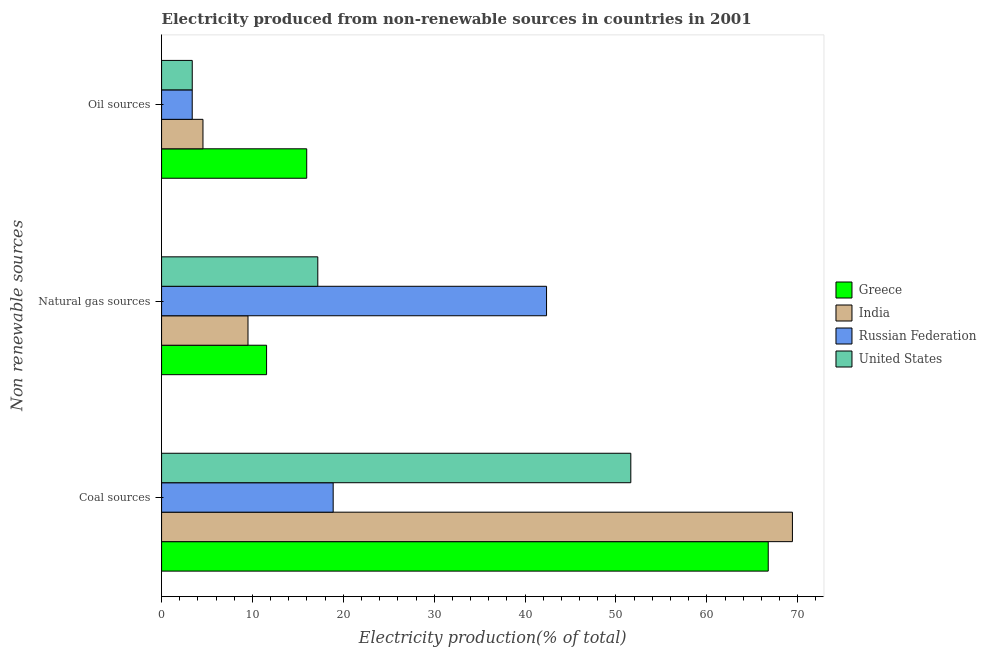How many different coloured bars are there?
Offer a very short reply. 4. How many groups of bars are there?
Keep it short and to the point. 3. How many bars are there on the 3rd tick from the top?
Your answer should be compact. 4. What is the label of the 3rd group of bars from the top?
Ensure brevity in your answer.  Coal sources. What is the percentage of electricity produced by natural gas in India?
Offer a terse response. 9.51. Across all countries, what is the maximum percentage of electricity produced by natural gas?
Offer a very short reply. 42.36. Across all countries, what is the minimum percentage of electricity produced by natural gas?
Your response must be concise. 9.51. In which country was the percentage of electricity produced by coal minimum?
Provide a short and direct response. Russian Federation. What is the total percentage of electricity produced by coal in the graph?
Provide a succinct answer. 206.69. What is the difference between the percentage of electricity produced by natural gas in Greece and that in Russian Federation?
Keep it short and to the point. -30.81. What is the difference between the percentage of electricity produced by natural gas in India and the percentage of electricity produced by oil sources in Greece?
Your answer should be very brief. -6.46. What is the average percentage of electricity produced by natural gas per country?
Offer a terse response. 20.15. What is the difference between the percentage of electricity produced by coal and percentage of electricity produced by natural gas in India?
Offer a terse response. 59.91. What is the ratio of the percentage of electricity produced by natural gas in Russian Federation to that in India?
Ensure brevity in your answer.  4.45. Is the difference between the percentage of electricity produced by oil sources in Greece and India greater than the difference between the percentage of electricity produced by natural gas in Greece and India?
Keep it short and to the point. Yes. What is the difference between the highest and the second highest percentage of electricity produced by coal?
Offer a very short reply. 2.66. What is the difference between the highest and the lowest percentage of electricity produced by natural gas?
Provide a succinct answer. 32.85. What does the 2nd bar from the top in Coal sources represents?
Make the answer very short. Russian Federation. What does the 3rd bar from the bottom in Coal sources represents?
Offer a very short reply. Russian Federation. Is it the case that in every country, the sum of the percentage of electricity produced by coal and percentage of electricity produced by natural gas is greater than the percentage of electricity produced by oil sources?
Provide a succinct answer. Yes. What is the difference between two consecutive major ticks on the X-axis?
Provide a succinct answer. 10. How many legend labels are there?
Provide a short and direct response. 4. What is the title of the graph?
Give a very brief answer. Electricity produced from non-renewable sources in countries in 2001. What is the label or title of the Y-axis?
Ensure brevity in your answer.  Non renewable sources. What is the Electricity production(% of total) of Greece in Coal sources?
Provide a short and direct response. 66.76. What is the Electricity production(% of total) of India in Coal sources?
Offer a terse response. 69.42. What is the Electricity production(% of total) of Russian Federation in Coal sources?
Provide a succinct answer. 18.88. What is the Electricity production(% of total) of United States in Coal sources?
Give a very brief answer. 51.63. What is the Electricity production(% of total) in Greece in Natural gas sources?
Provide a succinct answer. 11.56. What is the Electricity production(% of total) of India in Natural gas sources?
Offer a very short reply. 9.51. What is the Electricity production(% of total) of Russian Federation in Natural gas sources?
Your response must be concise. 42.36. What is the Electricity production(% of total) in United States in Natural gas sources?
Your answer should be compact. 17.19. What is the Electricity production(% of total) in Greece in Oil sources?
Give a very brief answer. 15.97. What is the Electricity production(% of total) in India in Oil sources?
Keep it short and to the point. 4.55. What is the Electricity production(% of total) in Russian Federation in Oil sources?
Provide a succinct answer. 3.37. What is the Electricity production(% of total) of United States in Oil sources?
Your answer should be compact. 3.37. Across all Non renewable sources, what is the maximum Electricity production(% of total) of Greece?
Offer a very short reply. 66.76. Across all Non renewable sources, what is the maximum Electricity production(% of total) of India?
Provide a succinct answer. 69.42. Across all Non renewable sources, what is the maximum Electricity production(% of total) of Russian Federation?
Offer a very short reply. 42.36. Across all Non renewable sources, what is the maximum Electricity production(% of total) in United States?
Ensure brevity in your answer.  51.63. Across all Non renewable sources, what is the minimum Electricity production(% of total) in Greece?
Provide a succinct answer. 11.56. Across all Non renewable sources, what is the minimum Electricity production(% of total) of India?
Keep it short and to the point. 4.55. Across all Non renewable sources, what is the minimum Electricity production(% of total) of Russian Federation?
Keep it short and to the point. 3.37. Across all Non renewable sources, what is the minimum Electricity production(% of total) in United States?
Your answer should be compact. 3.37. What is the total Electricity production(% of total) in Greece in the graph?
Offer a terse response. 94.28. What is the total Electricity production(% of total) in India in the graph?
Provide a succinct answer. 83.48. What is the total Electricity production(% of total) in Russian Federation in the graph?
Provide a short and direct response. 64.62. What is the total Electricity production(% of total) of United States in the graph?
Your answer should be very brief. 72.2. What is the difference between the Electricity production(% of total) of Greece in Coal sources and that in Natural gas sources?
Keep it short and to the point. 55.2. What is the difference between the Electricity production(% of total) of India in Coal sources and that in Natural gas sources?
Make the answer very short. 59.91. What is the difference between the Electricity production(% of total) in Russian Federation in Coal sources and that in Natural gas sources?
Provide a succinct answer. -23.48. What is the difference between the Electricity production(% of total) of United States in Coal sources and that in Natural gas sources?
Provide a succinct answer. 34.44. What is the difference between the Electricity production(% of total) of Greece in Coal sources and that in Oil sources?
Provide a succinct answer. 50.78. What is the difference between the Electricity production(% of total) of India in Coal sources and that in Oil sources?
Keep it short and to the point. 64.86. What is the difference between the Electricity production(% of total) in Russian Federation in Coal sources and that in Oil sources?
Offer a terse response. 15.51. What is the difference between the Electricity production(% of total) in United States in Coal sources and that in Oil sources?
Offer a terse response. 48.26. What is the difference between the Electricity production(% of total) of Greece in Natural gas sources and that in Oil sources?
Offer a terse response. -4.42. What is the difference between the Electricity production(% of total) of India in Natural gas sources and that in Oil sources?
Make the answer very short. 4.95. What is the difference between the Electricity production(% of total) of Russian Federation in Natural gas sources and that in Oil sources?
Make the answer very short. 38.99. What is the difference between the Electricity production(% of total) in United States in Natural gas sources and that in Oil sources?
Give a very brief answer. 13.82. What is the difference between the Electricity production(% of total) in Greece in Coal sources and the Electricity production(% of total) in India in Natural gas sources?
Your response must be concise. 57.25. What is the difference between the Electricity production(% of total) in Greece in Coal sources and the Electricity production(% of total) in Russian Federation in Natural gas sources?
Your response must be concise. 24.39. What is the difference between the Electricity production(% of total) of Greece in Coal sources and the Electricity production(% of total) of United States in Natural gas sources?
Give a very brief answer. 49.56. What is the difference between the Electricity production(% of total) of India in Coal sources and the Electricity production(% of total) of Russian Federation in Natural gas sources?
Your answer should be very brief. 27.05. What is the difference between the Electricity production(% of total) in India in Coal sources and the Electricity production(% of total) in United States in Natural gas sources?
Your answer should be compact. 52.23. What is the difference between the Electricity production(% of total) of Russian Federation in Coal sources and the Electricity production(% of total) of United States in Natural gas sources?
Make the answer very short. 1.69. What is the difference between the Electricity production(% of total) of Greece in Coal sources and the Electricity production(% of total) of India in Oil sources?
Your response must be concise. 62.2. What is the difference between the Electricity production(% of total) in Greece in Coal sources and the Electricity production(% of total) in Russian Federation in Oil sources?
Ensure brevity in your answer.  63.38. What is the difference between the Electricity production(% of total) of Greece in Coal sources and the Electricity production(% of total) of United States in Oil sources?
Offer a very short reply. 63.38. What is the difference between the Electricity production(% of total) in India in Coal sources and the Electricity production(% of total) in Russian Federation in Oil sources?
Give a very brief answer. 66.04. What is the difference between the Electricity production(% of total) in India in Coal sources and the Electricity production(% of total) in United States in Oil sources?
Make the answer very short. 66.04. What is the difference between the Electricity production(% of total) in Russian Federation in Coal sources and the Electricity production(% of total) in United States in Oil sources?
Keep it short and to the point. 15.51. What is the difference between the Electricity production(% of total) of Greece in Natural gas sources and the Electricity production(% of total) of India in Oil sources?
Provide a succinct answer. 7. What is the difference between the Electricity production(% of total) of Greece in Natural gas sources and the Electricity production(% of total) of Russian Federation in Oil sources?
Keep it short and to the point. 8.18. What is the difference between the Electricity production(% of total) of Greece in Natural gas sources and the Electricity production(% of total) of United States in Oil sources?
Provide a short and direct response. 8.18. What is the difference between the Electricity production(% of total) in India in Natural gas sources and the Electricity production(% of total) in Russian Federation in Oil sources?
Your answer should be compact. 6.14. What is the difference between the Electricity production(% of total) of India in Natural gas sources and the Electricity production(% of total) of United States in Oil sources?
Offer a very short reply. 6.13. What is the difference between the Electricity production(% of total) in Russian Federation in Natural gas sources and the Electricity production(% of total) in United States in Oil sources?
Offer a very short reply. 38.99. What is the average Electricity production(% of total) in Greece per Non renewable sources?
Your answer should be compact. 31.43. What is the average Electricity production(% of total) in India per Non renewable sources?
Provide a short and direct response. 27.83. What is the average Electricity production(% of total) of Russian Federation per Non renewable sources?
Make the answer very short. 21.54. What is the average Electricity production(% of total) of United States per Non renewable sources?
Your answer should be very brief. 24.07. What is the difference between the Electricity production(% of total) in Greece and Electricity production(% of total) in India in Coal sources?
Provide a short and direct response. -2.66. What is the difference between the Electricity production(% of total) of Greece and Electricity production(% of total) of Russian Federation in Coal sources?
Your response must be concise. 47.87. What is the difference between the Electricity production(% of total) in Greece and Electricity production(% of total) in United States in Coal sources?
Ensure brevity in your answer.  15.12. What is the difference between the Electricity production(% of total) of India and Electricity production(% of total) of Russian Federation in Coal sources?
Ensure brevity in your answer.  50.53. What is the difference between the Electricity production(% of total) of India and Electricity production(% of total) of United States in Coal sources?
Your answer should be very brief. 17.78. What is the difference between the Electricity production(% of total) in Russian Federation and Electricity production(% of total) in United States in Coal sources?
Offer a terse response. -32.75. What is the difference between the Electricity production(% of total) of Greece and Electricity production(% of total) of India in Natural gas sources?
Your response must be concise. 2.05. What is the difference between the Electricity production(% of total) in Greece and Electricity production(% of total) in Russian Federation in Natural gas sources?
Offer a terse response. -30.81. What is the difference between the Electricity production(% of total) of Greece and Electricity production(% of total) of United States in Natural gas sources?
Your answer should be very brief. -5.64. What is the difference between the Electricity production(% of total) of India and Electricity production(% of total) of Russian Federation in Natural gas sources?
Make the answer very short. -32.85. What is the difference between the Electricity production(% of total) of India and Electricity production(% of total) of United States in Natural gas sources?
Make the answer very short. -7.68. What is the difference between the Electricity production(% of total) of Russian Federation and Electricity production(% of total) of United States in Natural gas sources?
Offer a terse response. 25.17. What is the difference between the Electricity production(% of total) of Greece and Electricity production(% of total) of India in Oil sources?
Your answer should be very brief. 11.42. What is the difference between the Electricity production(% of total) in Greece and Electricity production(% of total) in Russian Federation in Oil sources?
Keep it short and to the point. 12.6. What is the difference between the Electricity production(% of total) in Greece and Electricity production(% of total) in United States in Oil sources?
Offer a terse response. 12.6. What is the difference between the Electricity production(% of total) in India and Electricity production(% of total) in Russian Federation in Oil sources?
Your response must be concise. 1.18. What is the difference between the Electricity production(% of total) of India and Electricity production(% of total) of United States in Oil sources?
Offer a very short reply. 1.18. What is the difference between the Electricity production(% of total) of Russian Federation and Electricity production(% of total) of United States in Oil sources?
Provide a short and direct response. -0. What is the ratio of the Electricity production(% of total) in Greece in Coal sources to that in Natural gas sources?
Offer a terse response. 5.78. What is the ratio of the Electricity production(% of total) of India in Coal sources to that in Natural gas sources?
Keep it short and to the point. 7.3. What is the ratio of the Electricity production(% of total) in Russian Federation in Coal sources to that in Natural gas sources?
Ensure brevity in your answer.  0.45. What is the ratio of the Electricity production(% of total) of United States in Coal sources to that in Natural gas sources?
Keep it short and to the point. 3. What is the ratio of the Electricity production(% of total) of Greece in Coal sources to that in Oil sources?
Your answer should be very brief. 4.18. What is the ratio of the Electricity production(% of total) in India in Coal sources to that in Oil sources?
Offer a terse response. 15.24. What is the ratio of the Electricity production(% of total) of Russian Federation in Coal sources to that in Oil sources?
Provide a succinct answer. 5.6. What is the ratio of the Electricity production(% of total) of United States in Coal sources to that in Oil sources?
Your response must be concise. 15.3. What is the ratio of the Electricity production(% of total) in Greece in Natural gas sources to that in Oil sources?
Make the answer very short. 0.72. What is the ratio of the Electricity production(% of total) of India in Natural gas sources to that in Oil sources?
Keep it short and to the point. 2.09. What is the ratio of the Electricity production(% of total) of Russian Federation in Natural gas sources to that in Oil sources?
Provide a short and direct response. 12.56. What is the ratio of the Electricity production(% of total) of United States in Natural gas sources to that in Oil sources?
Your answer should be very brief. 5.09. What is the difference between the highest and the second highest Electricity production(% of total) in Greece?
Provide a succinct answer. 50.78. What is the difference between the highest and the second highest Electricity production(% of total) in India?
Offer a very short reply. 59.91. What is the difference between the highest and the second highest Electricity production(% of total) of Russian Federation?
Offer a terse response. 23.48. What is the difference between the highest and the second highest Electricity production(% of total) of United States?
Provide a succinct answer. 34.44. What is the difference between the highest and the lowest Electricity production(% of total) in Greece?
Ensure brevity in your answer.  55.2. What is the difference between the highest and the lowest Electricity production(% of total) in India?
Your response must be concise. 64.86. What is the difference between the highest and the lowest Electricity production(% of total) in Russian Federation?
Offer a terse response. 38.99. What is the difference between the highest and the lowest Electricity production(% of total) of United States?
Offer a very short reply. 48.26. 